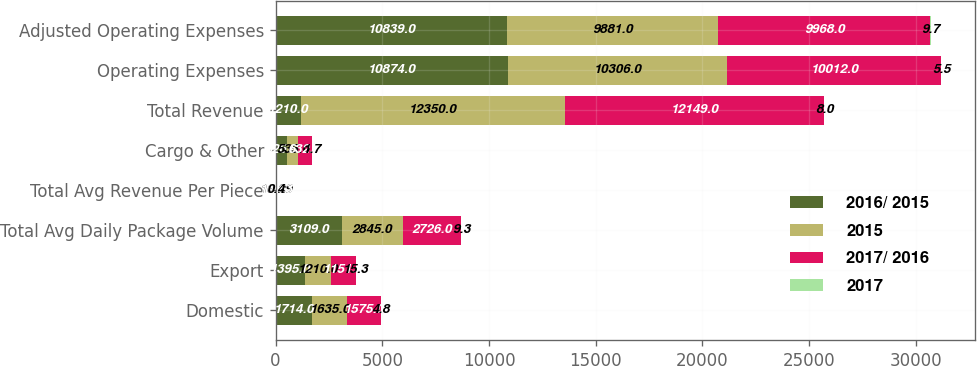Convert chart to OTSL. <chart><loc_0><loc_0><loc_500><loc_500><stacked_bar_chart><ecel><fcel>Domestic<fcel>Export<fcel>Total Avg Daily Package Volume<fcel>Total Avg Revenue Per Piece<fcel>Cargo & Other<fcel>Total Revenue<fcel>Operating Expenses<fcel>Adjusted Operating Expenses<nl><fcel>2016/ 2015<fcel>1714<fcel>1395<fcel>3109<fcel>16.22<fcel>526<fcel>1210<fcel>10874<fcel>10839<nl><fcel>2015<fcel>1635<fcel>1210<fcel>2845<fcel>16.29<fcel>535<fcel>12350<fcel>10306<fcel>9881<nl><fcel>2017/ 2016<fcel>1575<fcel>1151<fcel>2726<fcel>16.63<fcel>632<fcel>12149<fcel>10012<fcel>9968<nl><fcel>2017<fcel>4.8<fcel>15.3<fcel>9.3<fcel>0.4<fcel>1.7<fcel>8<fcel>5.5<fcel>9.7<nl></chart> 